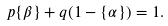<formula> <loc_0><loc_0><loc_500><loc_500>p \{ \beta \} + q ( 1 - \{ \alpha \} ) = 1 .</formula> 